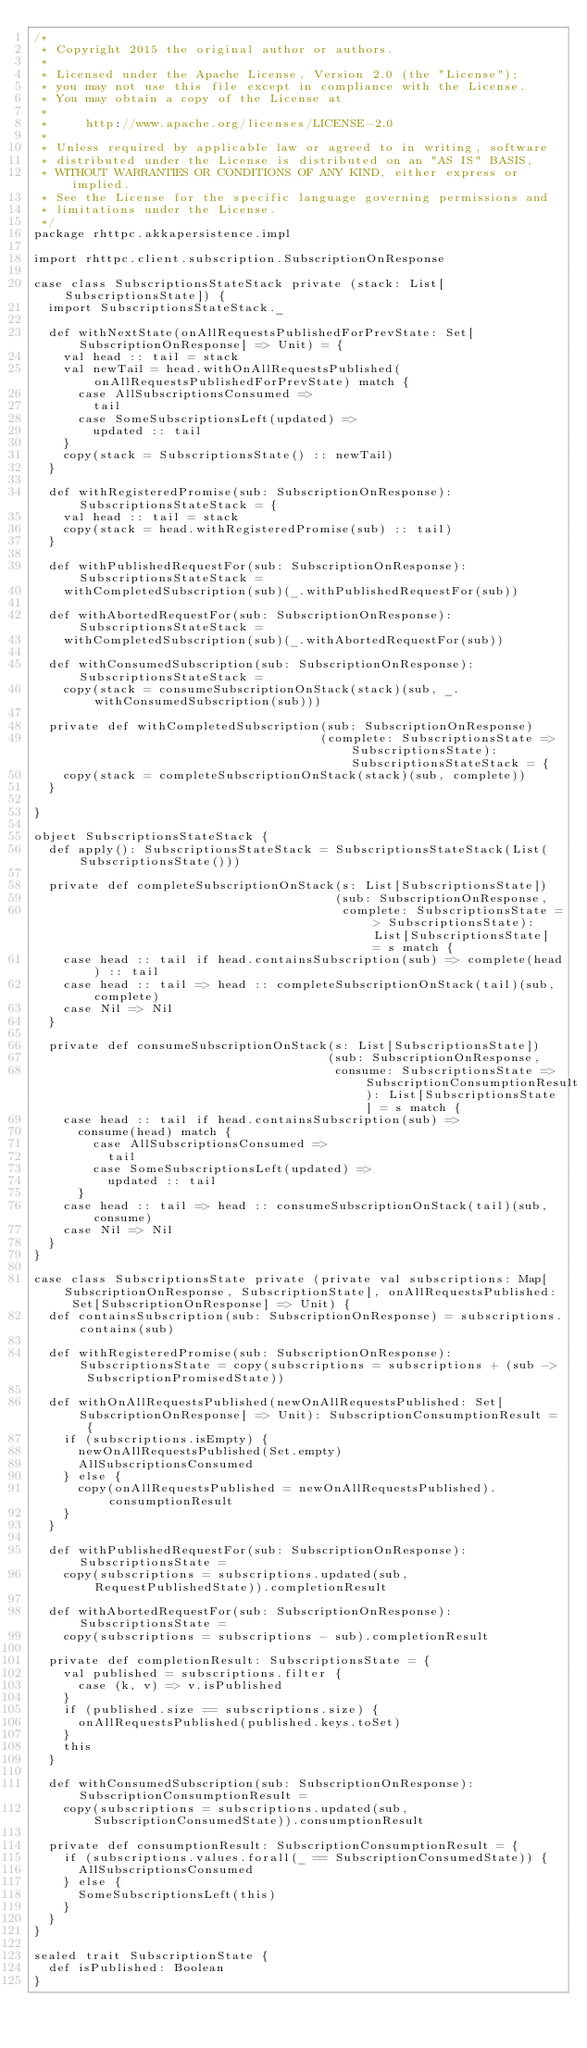<code> <loc_0><loc_0><loc_500><loc_500><_Scala_>/*
 * Copyright 2015 the original author or authors.
 *
 * Licensed under the Apache License, Version 2.0 (the "License");
 * you may not use this file except in compliance with the License.
 * You may obtain a copy of the License at
 *
 *     http://www.apache.org/licenses/LICENSE-2.0
 *
 * Unless required by applicable law or agreed to in writing, software
 * distributed under the License is distributed on an "AS IS" BASIS,
 * WITHOUT WARRANTIES OR CONDITIONS OF ANY KIND, either express or implied.
 * See the License for the specific language governing permissions and
 * limitations under the License.
 */
package rhttpc.akkapersistence.impl

import rhttpc.client.subscription.SubscriptionOnResponse

case class SubscriptionsStateStack private (stack: List[SubscriptionsState]) {
  import SubscriptionsStateStack._

  def withNextState(onAllRequestsPublishedForPrevState: Set[SubscriptionOnResponse] => Unit) = {
    val head :: tail = stack
    val newTail = head.withOnAllRequestsPublished(onAllRequestsPublishedForPrevState) match {
      case AllSubscriptionsConsumed =>
        tail
      case SomeSubscriptionsLeft(updated) =>
        updated :: tail
    }
    copy(stack = SubscriptionsState() :: newTail)
  }

  def withRegisteredPromise(sub: SubscriptionOnResponse): SubscriptionsStateStack = {
    val head :: tail = stack
    copy(stack = head.withRegisteredPromise(sub) :: tail)
  }

  def withPublishedRequestFor(sub: SubscriptionOnResponse): SubscriptionsStateStack =
    withCompletedSubscription(sub)(_.withPublishedRequestFor(sub))

  def withAbortedRequestFor(sub: SubscriptionOnResponse): SubscriptionsStateStack =
    withCompletedSubscription(sub)(_.withAbortedRequestFor(sub))

  def withConsumedSubscription(sub: SubscriptionOnResponse): SubscriptionsStateStack =
    copy(stack = consumeSubscriptionOnStack(stack)(sub, _.withConsumedSubscription(sub)))

  private def withCompletedSubscription(sub: SubscriptionOnResponse)
                                       (complete: SubscriptionsState => SubscriptionsState): SubscriptionsStateStack = {
    copy(stack = completeSubscriptionOnStack(stack)(sub, complete))
  }
  
}

object SubscriptionsStateStack {
  def apply(): SubscriptionsStateStack = SubscriptionsStateStack(List(SubscriptionsState()))
  
  private def completeSubscriptionOnStack(s: List[SubscriptionsState])
                                         (sub: SubscriptionOnResponse,
                                          complete: SubscriptionsState => SubscriptionsState): List[SubscriptionsState] = s match {
    case head :: tail if head.containsSubscription(sub) => complete(head) :: tail
    case head :: tail => head :: completeSubscriptionOnStack(tail)(sub, complete)
    case Nil => Nil
  }

  private def consumeSubscriptionOnStack(s: List[SubscriptionsState])
                                        (sub: SubscriptionOnResponse,
                                         consume: SubscriptionsState => SubscriptionConsumptionResult): List[SubscriptionsState] = s match {
    case head :: tail if head.containsSubscription(sub) =>
      consume(head) match {
        case AllSubscriptionsConsumed =>
          tail
        case SomeSubscriptionsLeft(updated) =>
          updated :: tail
      }
    case head :: tail => head :: consumeSubscriptionOnStack(tail)(sub, consume)
    case Nil => Nil
  }
}

case class SubscriptionsState private (private val subscriptions: Map[SubscriptionOnResponse, SubscriptionState], onAllRequestsPublished: Set[SubscriptionOnResponse] => Unit) {
  def containsSubscription(sub: SubscriptionOnResponse) = subscriptions.contains(sub)

  def withRegisteredPromise(sub: SubscriptionOnResponse): SubscriptionsState = copy(subscriptions = subscriptions + (sub -> SubscriptionPromisedState))

  def withOnAllRequestsPublished(newOnAllRequestsPublished: Set[SubscriptionOnResponse] => Unit): SubscriptionConsumptionResult = {
    if (subscriptions.isEmpty) {
      newOnAllRequestsPublished(Set.empty)
      AllSubscriptionsConsumed
    } else {
      copy(onAllRequestsPublished = newOnAllRequestsPublished).consumptionResult
    }
  }
  
  def withPublishedRequestFor(sub: SubscriptionOnResponse): SubscriptionsState =
    copy(subscriptions = subscriptions.updated(sub, RequestPublishedState)).completionResult

  def withAbortedRequestFor(sub: SubscriptionOnResponse): SubscriptionsState =
    copy(subscriptions = subscriptions - sub).completionResult
  
  private def completionResult: SubscriptionsState = {
    val published = subscriptions.filter {
      case (k, v) => v.isPublished
    }
    if (published.size == subscriptions.size) {
      onAllRequestsPublished(published.keys.toSet)
    }
    this
  }

  def withConsumedSubscription(sub: SubscriptionOnResponse): SubscriptionConsumptionResult =
    copy(subscriptions = subscriptions.updated(sub, SubscriptionConsumedState)).consumptionResult
  
  private def consumptionResult: SubscriptionConsumptionResult = {
    if (subscriptions.values.forall(_ == SubscriptionConsumedState)) {
      AllSubscriptionsConsumed
    } else {
      SomeSubscriptionsLeft(this)
    }
  }
}

sealed trait SubscriptionState {
  def isPublished: Boolean
}
</code> 